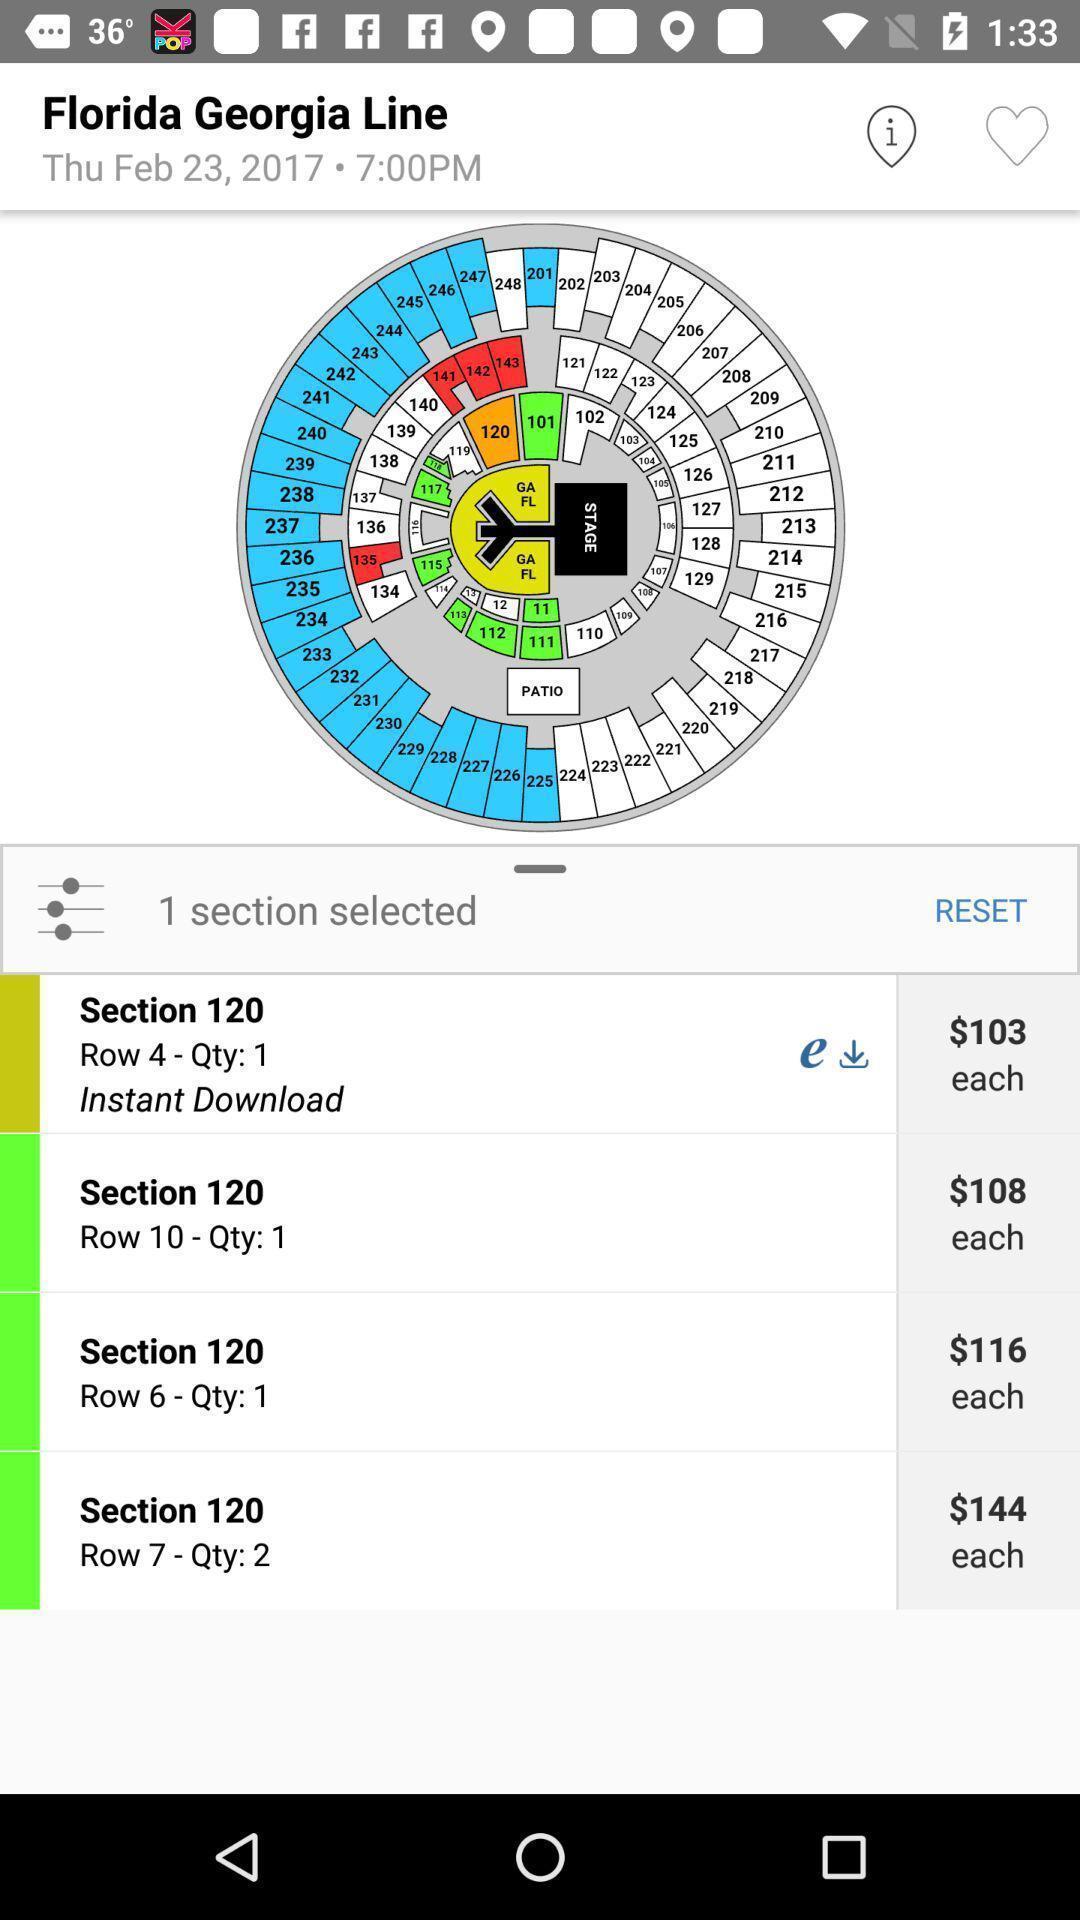Give me a summary of this screen capture. Page showing different tickets available. 